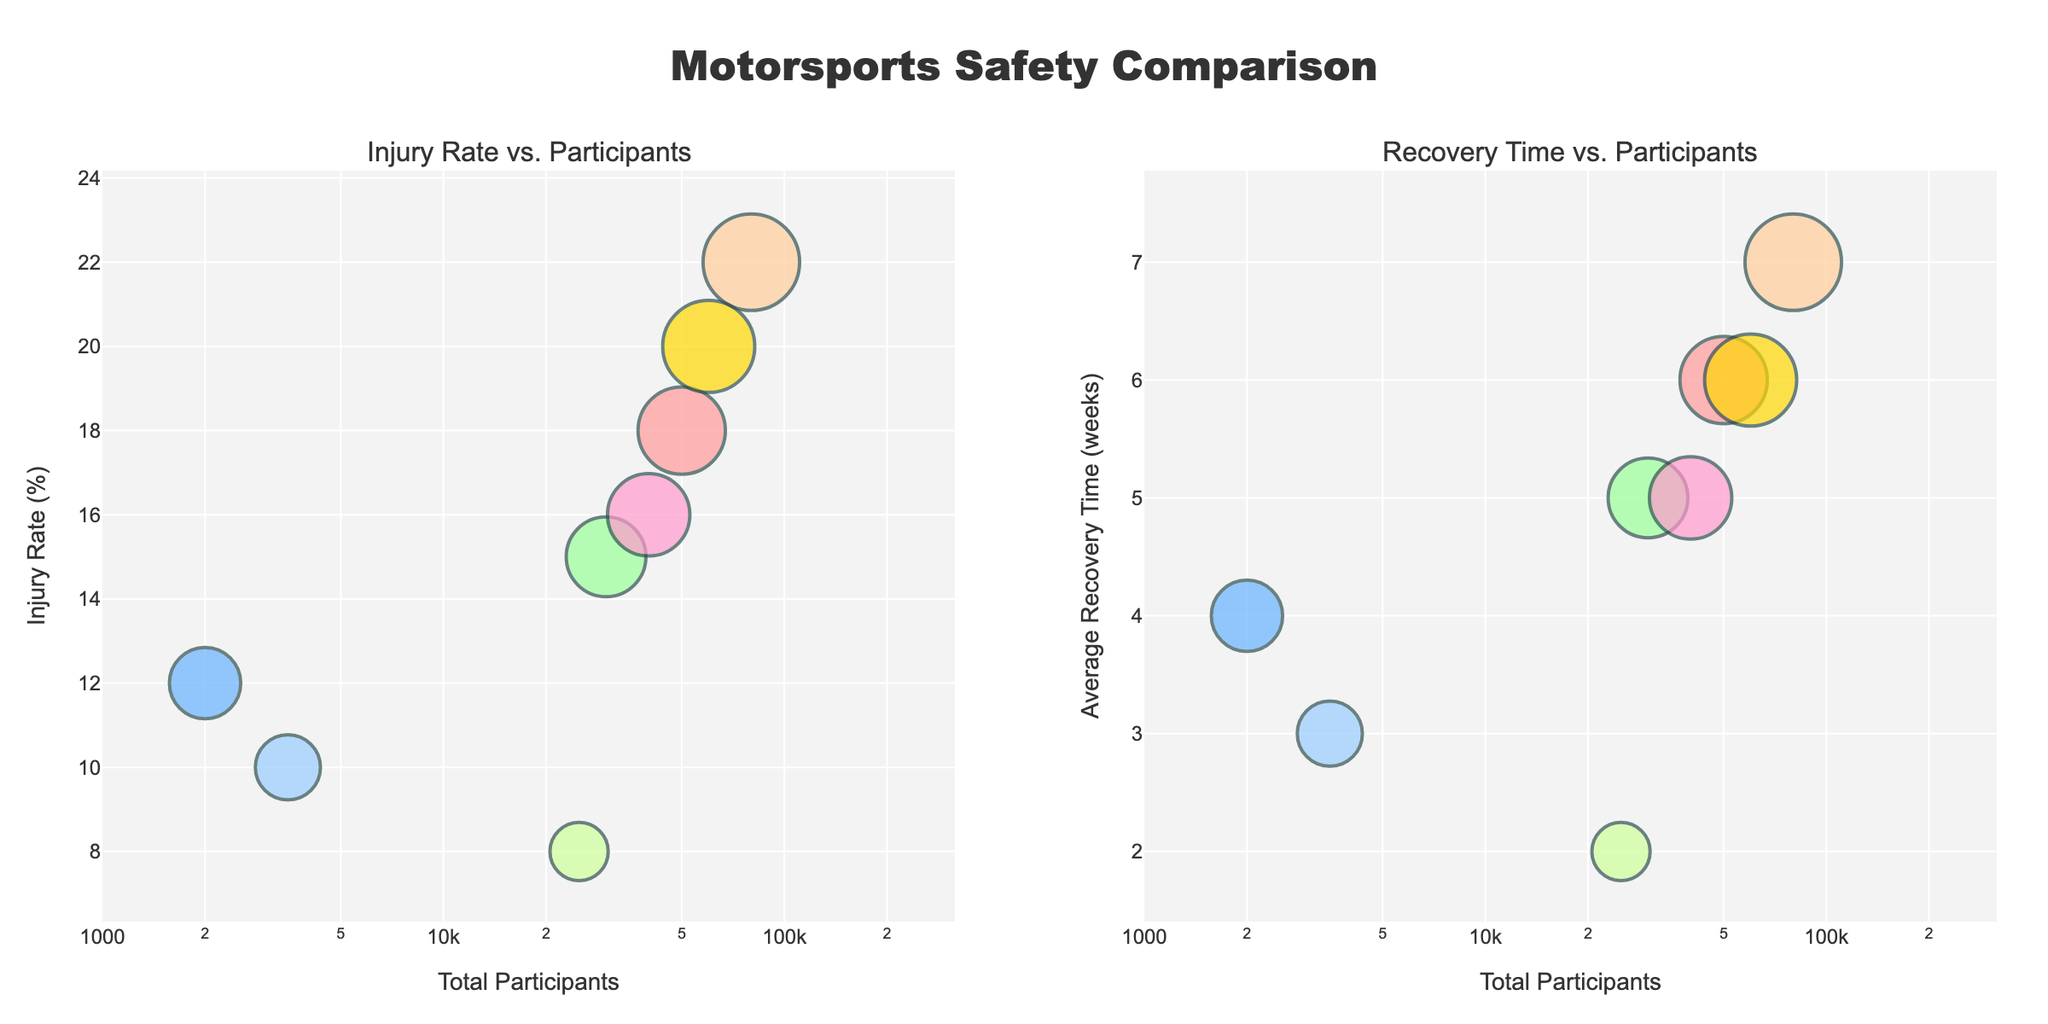What is the title of the figure? The title of the figure is displayed prominently at the top and reads "Motorsports Safety Comparison."
Answer: Motorsports Safety Comparison How many motorsport categories are compared in the figure? The figure compares 8 motorsport categories, as seen from the different colored bubbles representing each sport.
Answer: 8 Which motorsport has the highest injury rate? To find the highest injury rate, look at the y-axis of the "Injury Rate vs. Participants" plot and identify the highest bubble on the y-axis. The highest injury rate is 22% for Motocross.
Answer: Motocross Which sport has the lowest average recovery time? Check the "Recovery Time vs. Participants" plot and look for the lowest point on the y-axis. Drag Racing has an average recovery time of 2 weeks.
Answer: Drag Racing How does the total number of participants in Motocross compare to that of Motorcycle Racing? On the x-axis of both plots, compare the position of Motocross and Motorcycle Racing. Motocross has 80,000 participants, which is 30,000 more than the 50,000 participants of Motorcycle Racing.
Answer: Motocross has 30,000 more participants What is the average of the injury rates of Formula 1 and NASCAR? The injury rates are 12% for Formula 1 and 10% for NASCAR. Add the rates (12 + 10) and divide by 2 to find the average, which is (12+10)/2 = 11%.
Answer: 11% Which motorsport category has both a high injury rate and a long average recovery time? Look for categories that are in the upper part of the y-axis in both subplots. Motocross has a high injury rate (22%) and a long recovery time (7 weeks).
Answer: Motocross Which motorsport has the largest bubble size in the "Injury Rate vs. Participants" plot and what does it represent? The largest bubble in the "Injury Rate vs. Participants" plot corresponds to Motocross, representing the highest injury rate of 22%.
Answer: Motocross with 22% injury rate Is there any motorsport with both low injury rate and low recovery time? Look for bubbles in the lower part of the y-axis on both subplots. Drag Racing has the lowest injury rate (8%) and the lowest recovery time (2 weeks).
Answer: Drag Racing Which motorsport has an injury rate that is closest to the average recovery time for Motorcycle Racing? The injury rate for Motorcycle Racing is 18%, and we compare this to recovery times in the other plot. Enduro has a recovery time of 6 weeks, which is equal to the average recovery time of Motorcycle Racing.
Answer: Enduro 